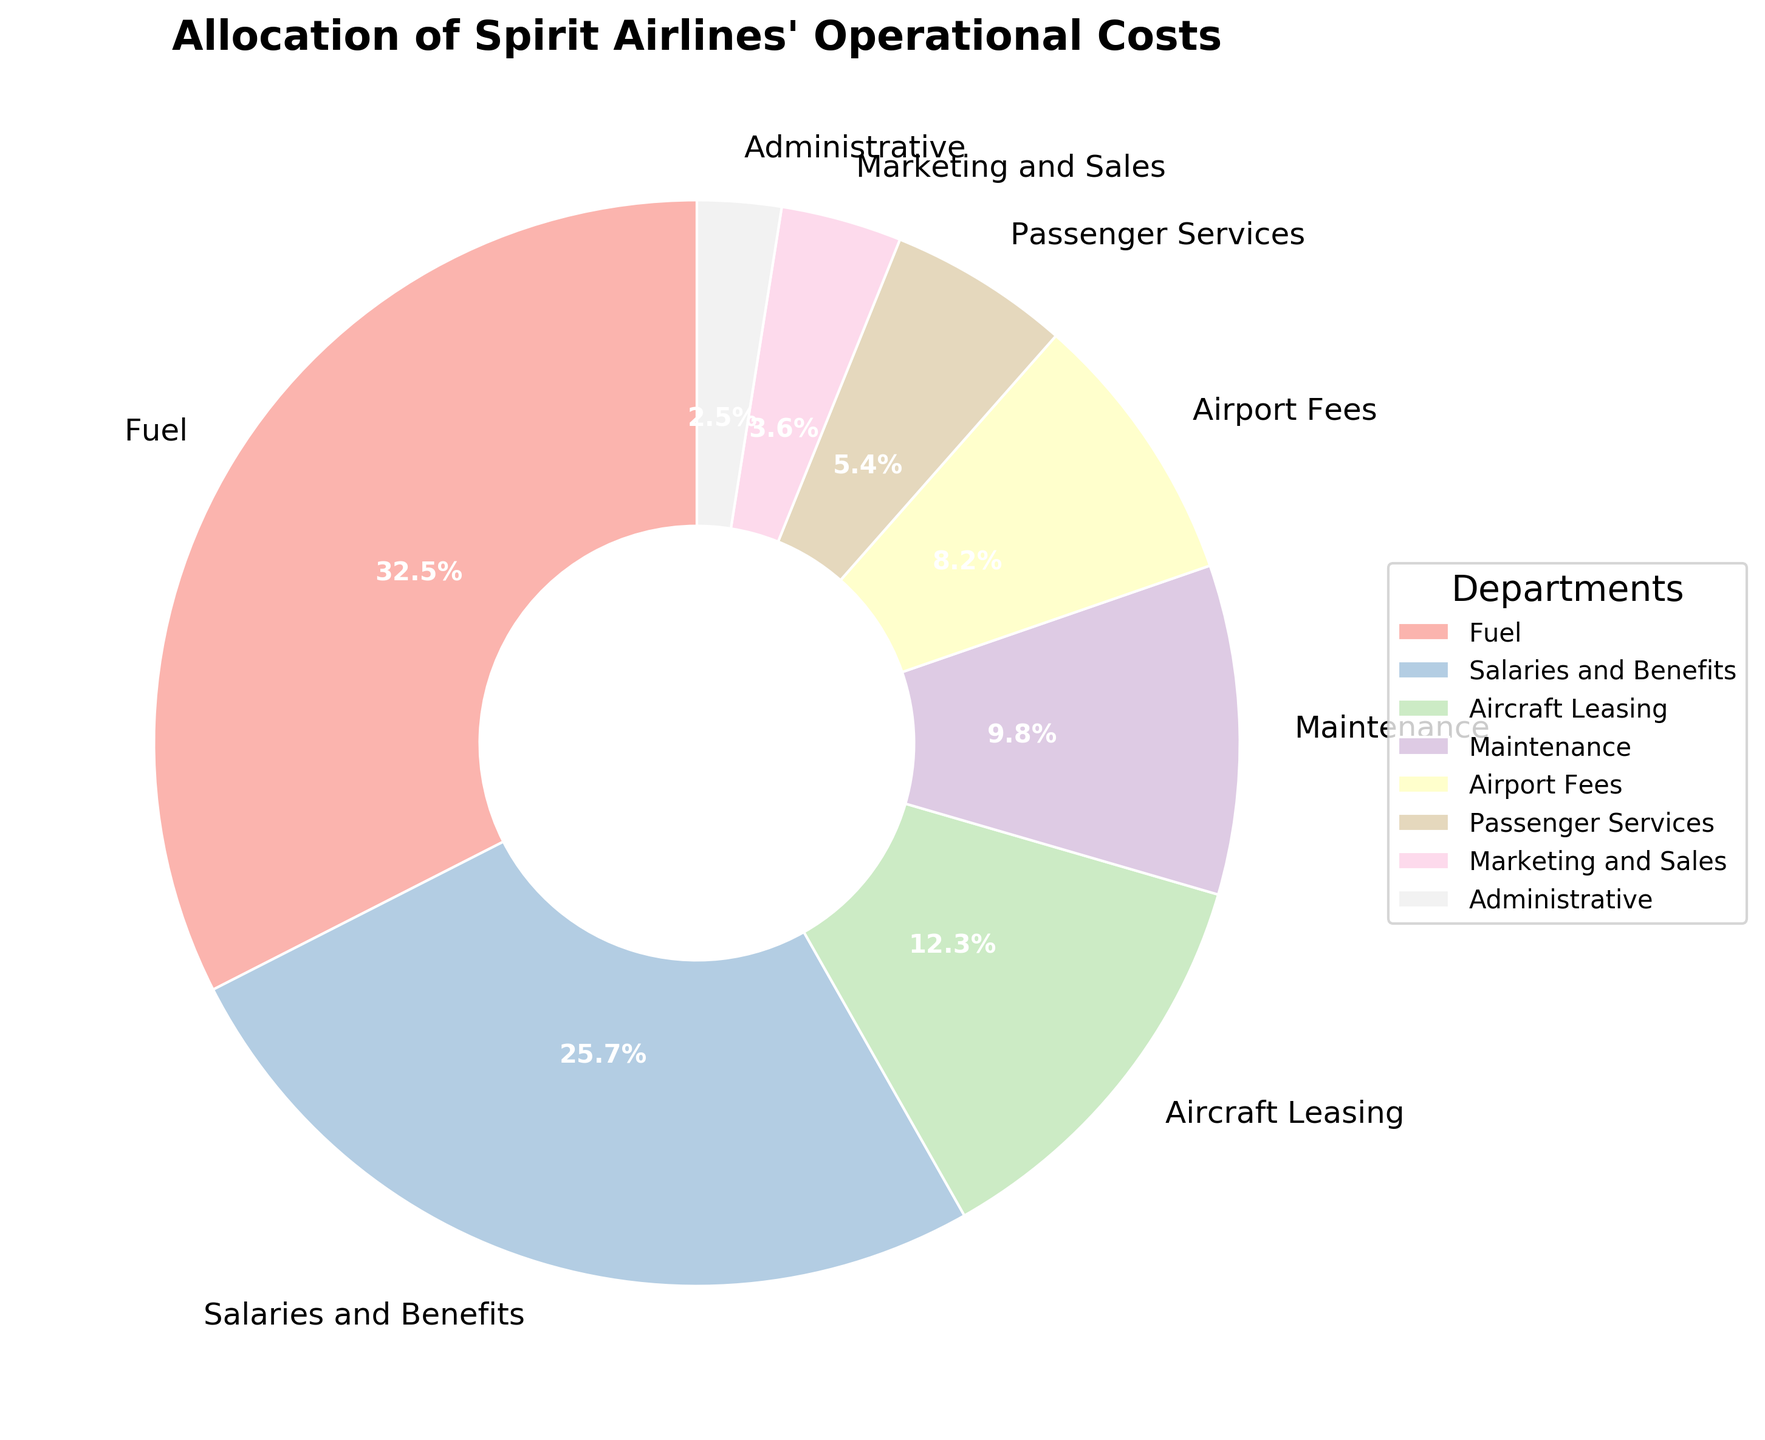What is the title of the pie chart? The title is positioned at the top of the pie chart. It provides a clear summary of what the chart represents.
Answer: Allocation of Spirit Airlines' Operational Costs What department has the highest operational cost percentage? By looking at the slices of the pie chart, the largest slice represents the department with the highest cost percentage.
Answer: Fuel What percentage of operational costs is attributed to Marketing and Sales and Administrative combined? Add the percentages for Marketing and Sales (3.6%) and Administrative (2.5%). 3.6 + 2.5 = 6.1
Answer: 6.1% Which department has a larger cost percentage, Aircraft Leasing or Maintenance? Compare the slices representing Aircraft Leasing (12.3%) and Maintenance (9.8%).
Answer: Aircraft Leasing How much more percentage is spent on Salaries and Benefits than on Passenger Services? Subtract the percentage of Passenger Services (5.4%) from Salaries and Benefits (25.7%). 25.7 - 5.4 = 20.3
Answer: 20.3% What color represents the Maintenance department on the pie chart? Identify the slice corresponding to the Maintenance department (9.8%) and describe its color. Maintenance is shown using one of the pastel colors, likely found in the middle of the color spectrum provided by Pastel1.
Answer: A pastel shade How many departments have an operational cost percentage less than 10%? Count the number of departments with percentages below 10%. The relevant departments are Maintenance (9.8%), Airport Fees (8.2%), Passenger Services (5.4%), Marketing and Sales (3.6%), and Administrative (2.5%). This totals to 5 departments.
Answer: 5 Which department's cost percentage is closest to 10%? Compare the cost percentages of the departments to see which is nearest to 10%. Maintenance has a cost percentage of 9.8%, which is closest to 10%.
Answer: Maintenance What is the combined operational cost percentage for Fuel, Salaries and Benefits, and Aircraft Leasing? Add the percentages for Fuel (32.5%), Salaries and Benefits (25.7%), and Aircraft Leasing (12.3%). 32.5 + 25.7 + 12.3 = 70.5
Answer: 70.5% What portion of the total operational costs is spent on categories other than Fuel and Salaries and Benefits? Add the percentages of all departments except Fuel (32.5%) and Salaries and Benefits (25.7%). The sum of Aircraft Leasing (12.3%), Maintenance (9.8%), Airport Fees (8.2%), Passenger Services (5.4%), Marketing and Sales (3.6%), and Administrative (2.5%) is 41.8%.
Answer: 41.8% 